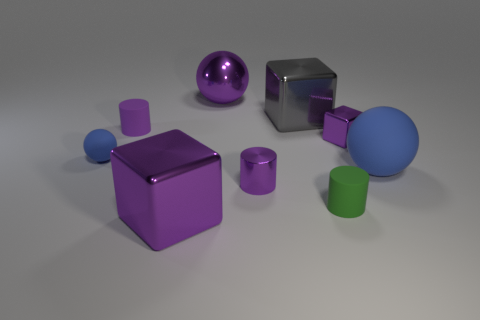What is the material of the purple object that is on the left side of the large purple cube? The object to the left of the large purple cube appears to be a glossy, spherical shape, suggesting it could be made of a smooth material like plastic or polished metal. However, without additional contextual information, we cannot definitively determine the material solely from visual inspection. 